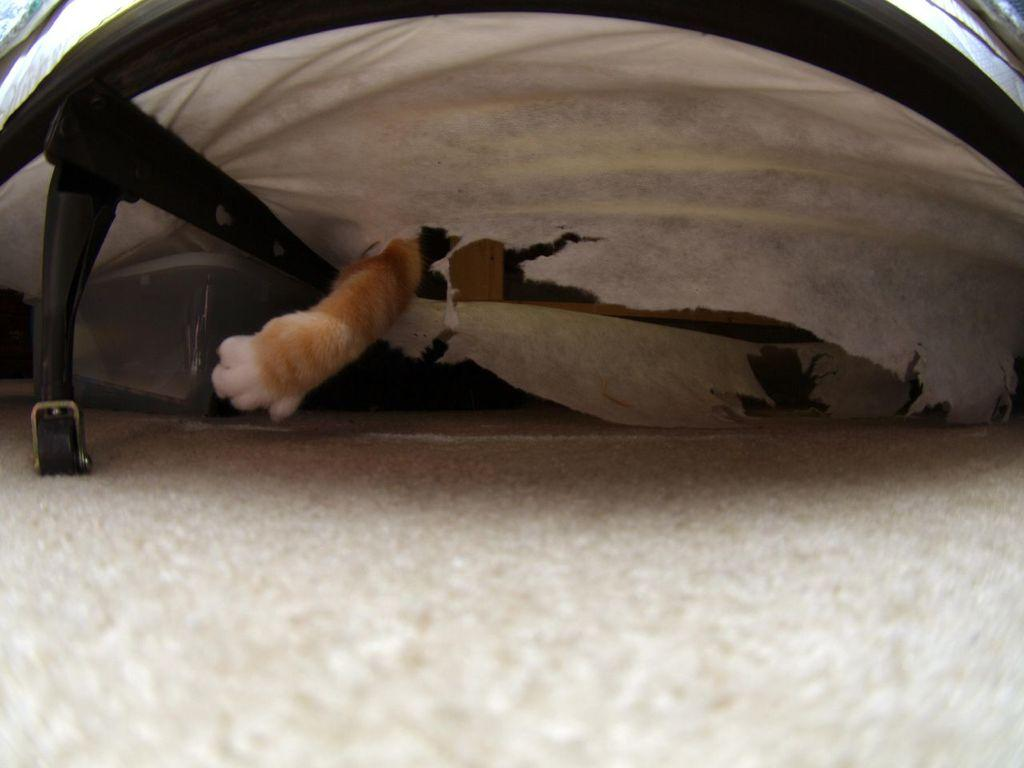What part of a cat can be seen in the image? There is a cat's leg in the image. What can be seen in the background of the image? There are white objects in the background of the image. Reasoning: Let's think step by step by step in order to produce the conversation. We start by identifying the main subject in the image, which is the cat's leg. Then, we expand the conversation to include the background of the image, noting that there are white objects present. Each question is designed to elicit a specific detail about the image that is known from the provided facts. Absurd Question/Answer: What type of flower is growing on the cat's leg in the image? There is no flower present on the cat's leg in the image. What type of leather material can be seen in the image? There is no leather material present in the image. 